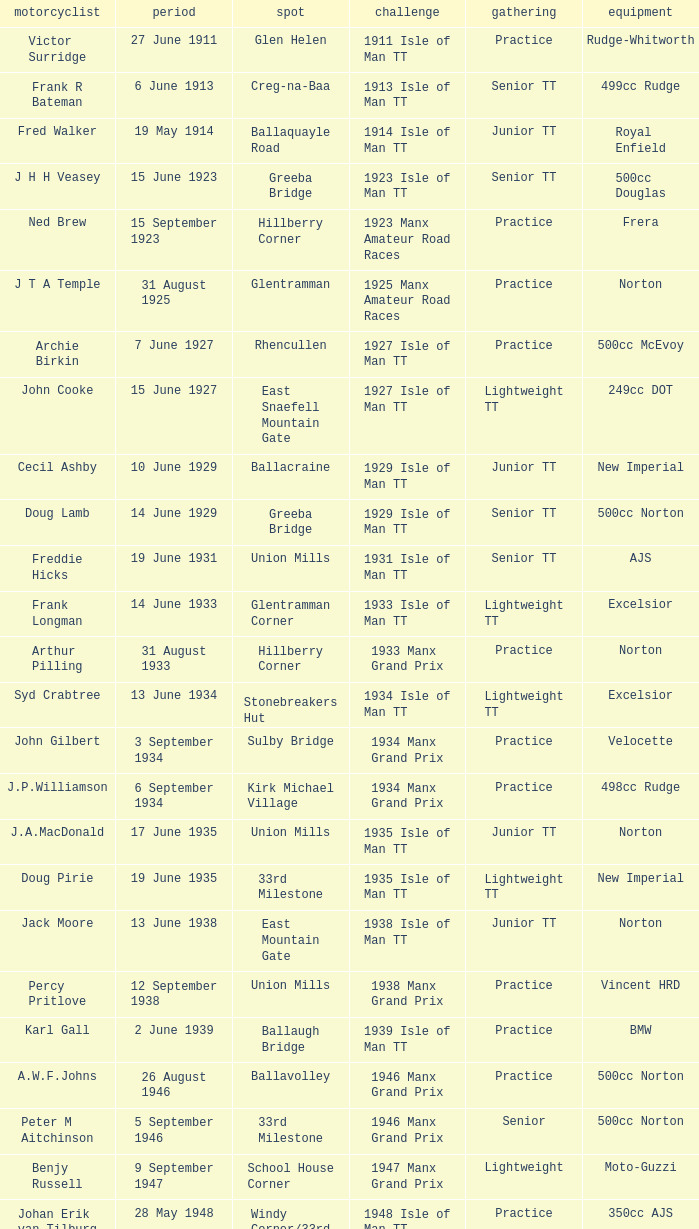What equipment did keith t. gawler mount? 499cc Norton. 